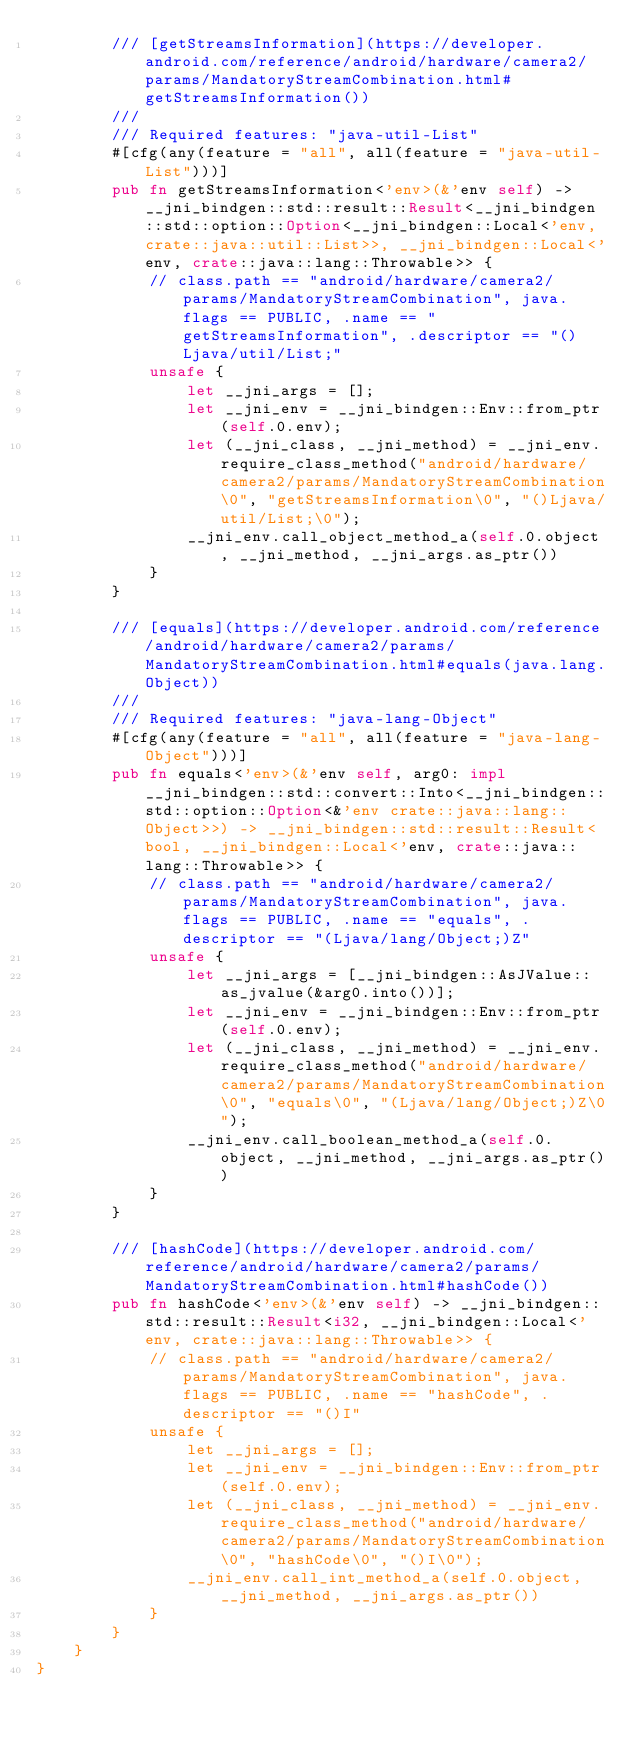<code> <loc_0><loc_0><loc_500><loc_500><_Rust_>        /// [getStreamsInformation](https://developer.android.com/reference/android/hardware/camera2/params/MandatoryStreamCombination.html#getStreamsInformation())
        ///
        /// Required features: "java-util-List"
        #[cfg(any(feature = "all", all(feature = "java-util-List")))]
        pub fn getStreamsInformation<'env>(&'env self) -> __jni_bindgen::std::result::Result<__jni_bindgen::std::option::Option<__jni_bindgen::Local<'env, crate::java::util::List>>, __jni_bindgen::Local<'env, crate::java::lang::Throwable>> {
            // class.path == "android/hardware/camera2/params/MandatoryStreamCombination", java.flags == PUBLIC, .name == "getStreamsInformation", .descriptor == "()Ljava/util/List;"
            unsafe {
                let __jni_args = [];
                let __jni_env = __jni_bindgen::Env::from_ptr(self.0.env);
                let (__jni_class, __jni_method) = __jni_env.require_class_method("android/hardware/camera2/params/MandatoryStreamCombination\0", "getStreamsInformation\0", "()Ljava/util/List;\0");
                __jni_env.call_object_method_a(self.0.object, __jni_method, __jni_args.as_ptr())
            }
        }

        /// [equals](https://developer.android.com/reference/android/hardware/camera2/params/MandatoryStreamCombination.html#equals(java.lang.Object))
        ///
        /// Required features: "java-lang-Object"
        #[cfg(any(feature = "all", all(feature = "java-lang-Object")))]
        pub fn equals<'env>(&'env self, arg0: impl __jni_bindgen::std::convert::Into<__jni_bindgen::std::option::Option<&'env crate::java::lang::Object>>) -> __jni_bindgen::std::result::Result<bool, __jni_bindgen::Local<'env, crate::java::lang::Throwable>> {
            // class.path == "android/hardware/camera2/params/MandatoryStreamCombination", java.flags == PUBLIC, .name == "equals", .descriptor == "(Ljava/lang/Object;)Z"
            unsafe {
                let __jni_args = [__jni_bindgen::AsJValue::as_jvalue(&arg0.into())];
                let __jni_env = __jni_bindgen::Env::from_ptr(self.0.env);
                let (__jni_class, __jni_method) = __jni_env.require_class_method("android/hardware/camera2/params/MandatoryStreamCombination\0", "equals\0", "(Ljava/lang/Object;)Z\0");
                __jni_env.call_boolean_method_a(self.0.object, __jni_method, __jni_args.as_ptr())
            }
        }

        /// [hashCode](https://developer.android.com/reference/android/hardware/camera2/params/MandatoryStreamCombination.html#hashCode())
        pub fn hashCode<'env>(&'env self) -> __jni_bindgen::std::result::Result<i32, __jni_bindgen::Local<'env, crate::java::lang::Throwable>> {
            // class.path == "android/hardware/camera2/params/MandatoryStreamCombination", java.flags == PUBLIC, .name == "hashCode", .descriptor == "()I"
            unsafe {
                let __jni_args = [];
                let __jni_env = __jni_bindgen::Env::from_ptr(self.0.env);
                let (__jni_class, __jni_method) = __jni_env.require_class_method("android/hardware/camera2/params/MandatoryStreamCombination\0", "hashCode\0", "()I\0");
                __jni_env.call_int_method_a(self.0.object, __jni_method, __jni_args.as_ptr())
            }
        }
    }
}
</code> 